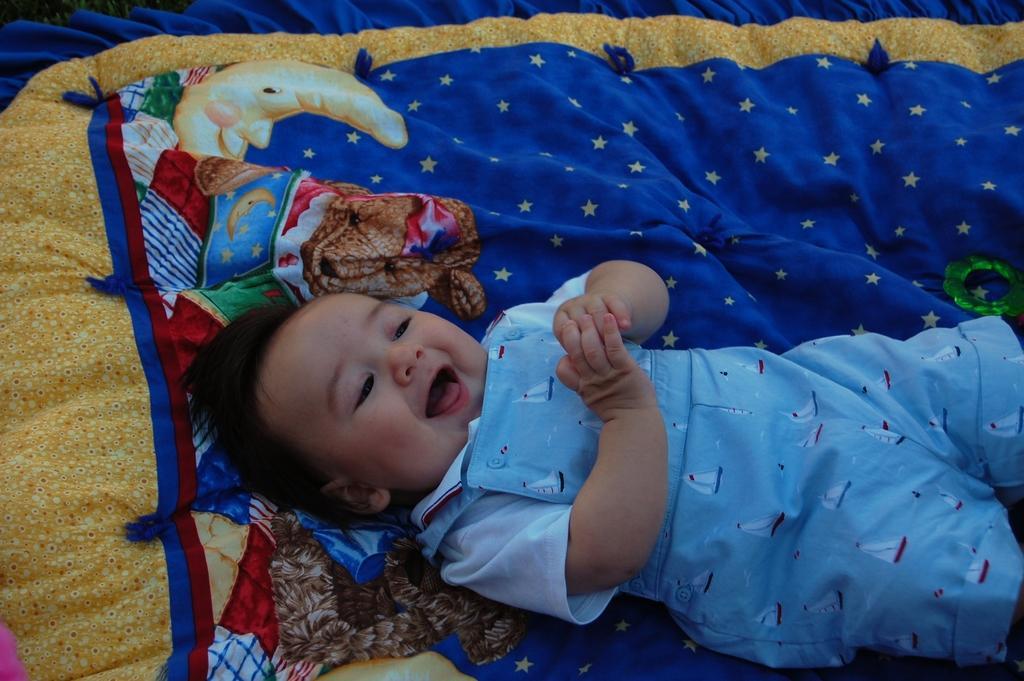Could you give a brief overview of what you see in this image? The picture consists of a baby. The baby is smiling. At the bottom we can see a blue color cloth. 